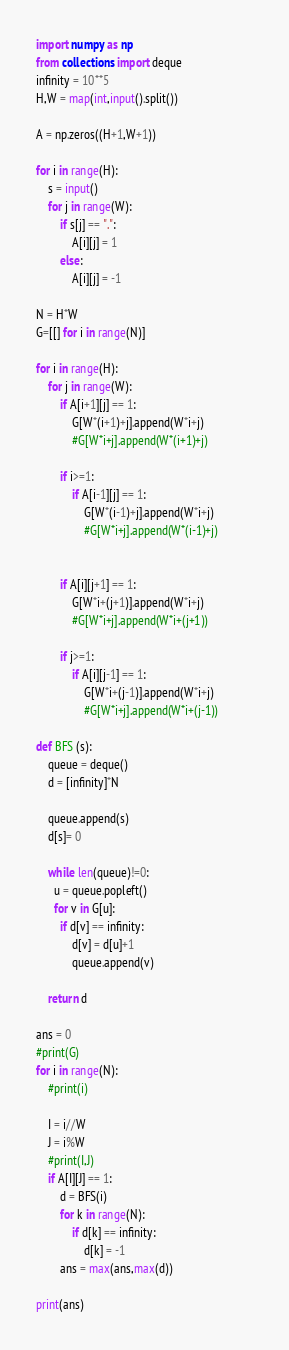Convert code to text. <code><loc_0><loc_0><loc_500><loc_500><_Python_>import numpy as np
from collections import deque
infinity = 10**5
H,W = map(int,input().split())

A = np.zeros((H+1,W+1))

for i in range(H):
    s = input()
    for j in range(W):
        if s[j] == ".":
            A[i][j] = 1
        else:
            A[i][j] = -1

N = H*W
G=[[] for i in range(N)]

for i in range(H):
    for j in range(W):
        if A[i+1][j] == 1:
            G[W*(i+1)+j].append(W*i+j)
            #G[W*i+j].append(W*(i+1)+j)

        if i>=1:
            if A[i-1][j] == 1:
                G[W*(i-1)+j].append(W*i+j)
                #G[W*i+j].append(W*(i-1)+j)            
            
        
        if A[i][j+1] == 1:
            G[W*i+(j+1)].append(W*i+j)
            #G[W*i+j].append(W*i+(j+1))
        
        if j>=1:
            if A[i][j-1] == 1:
                G[W*i+(j-1)].append(W*i+j)
                #G[W*i+j].append(W*i+(j-1))

def BFS (s):
    queue = deque()
    d = [infinity]*N
    
    queue.append(s)
    d[s]= 0
    
    while len(queue)!=0:
      u = queue.popleft()
      for v in G[u]:
      	if d[v] == infinity:
        	d[v] = d[u]+1
        	queue.append(v) 	  
  
    return d

ans = 0
#print(G)
for i in range(N):
    #print(i)
   
    I = i//W
    J = i%W
    #print(I,J)
    if A[I][J] == 1:
        d = BFS(i)
        for k in range(N):
            if d[k] == infinity:
                d[k] = -1
        ans = max(ans,max(d))

print(ans)</code> 